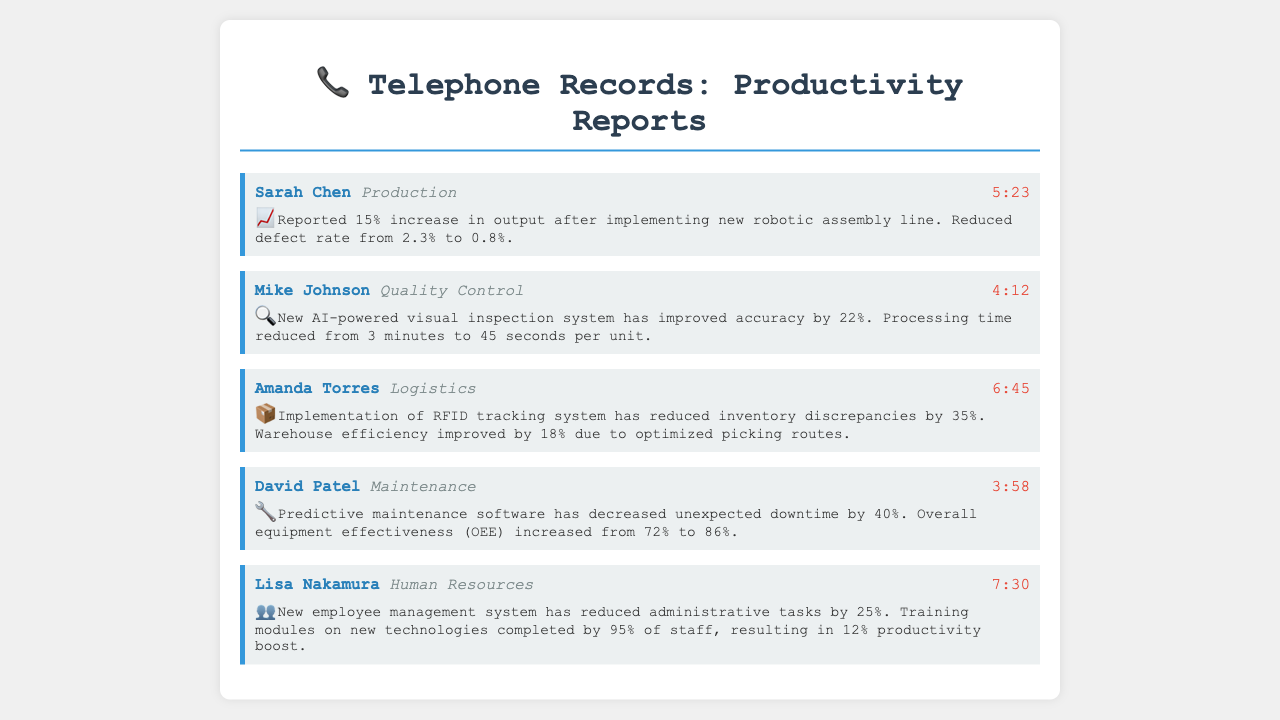What is the duration of Sarah Chen's call? The duration of Sarah Chen's call is indicated next to her name in the document, which is 5 minutes and 23 seconds.
Answer: 5:23 What percentage increase in output was reported by the Production department? The summary states that the Production department reported a 15% increase in output after implementing new technology.
Answer: 15% Who reported on the new AI-powered visual inspection system? The call record names Mike Johnson as the one who reported on the new AI-powered visual inspection system in the Quality Control department.
Answer: Mike Johnson What was the reduction in processing time per unit due to the new inspection system? The document details that the processing time was reduced from 3 minutes to 45 seconds per unit, which indicates a significant decrease in processing time.
Answer: 2 minutes 15 seconds What is the overall equipment effectiveness increase reported by the Maintenance department? The Maintenance department reported an increase in overall equipment effectiveness from 72% to 86%, which amounts to a 14% increase.
Answer: 14% Which department implemented an RFID tracking system? The RFID tracking system implementation was reported by Amanda Torres from the Logistics department, as per the call record.
Answer: Logistics How much did the new employee management system reduce administrative tasks? The document mentions that the new employee management system reduced administrative tasks by 25%.
Answer: 25% What icon is used in the summary for logistics-related productivity? The summary for logistics-related productivity uses the package emoji (📦) to represent it.
Answer: 📦 How much did inventory discrepancies decrease by after implementing the RFID system? The summary states that inventory discrepancies were reduced by 35% following the implementation of the RFID tracking system.
Answer: 35% 